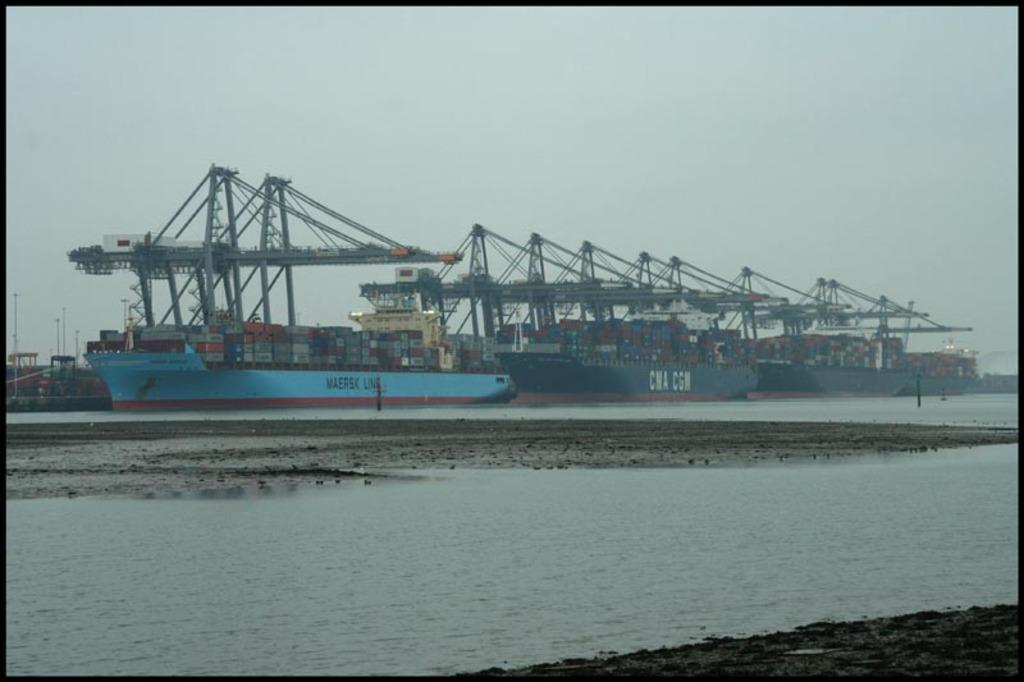Describe this image in one or two sentences. In this image there are ships on the sea, in the middle there is the land, in the background there is the sky. 